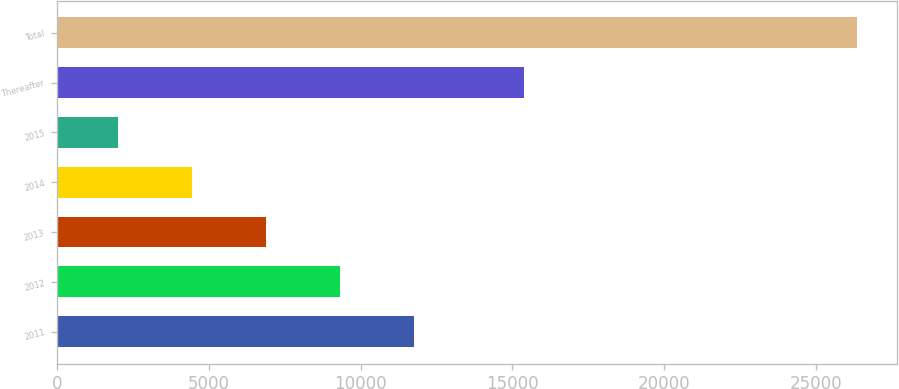<chart> <loc_0><loc_0><loc_500><loc_500><bar_chart><fcel>2011<fcel>2012<fcel>2013<fcel>2014<fcel>2015<fcel>Thereafter<fcel>Total<nl><fcel>11742.2<fcel>9306.9<fcel>6871.6<fcel>4436.3<fcel>2001<fcel>15379<fcel>26354<nl></chart> 